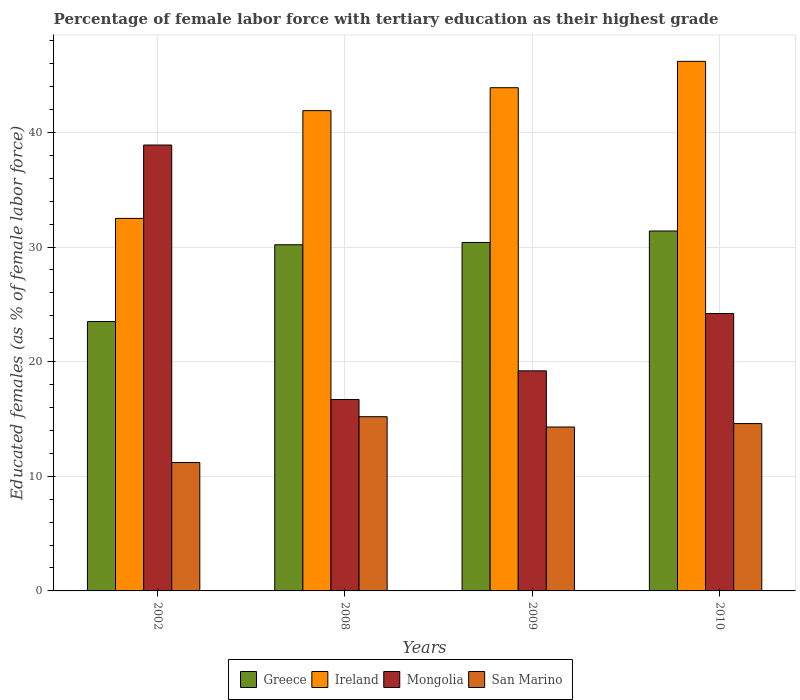In how many cases, is the number of bars for a given year not equal to the number of legend labels?
Ensure brevity in your answer.  0. What is the percentage of female labor force with tertiary education in Ireland in 2002?
Ensure brevity in your answer.  32.5. Across all years, what is the maximum percentage of female labor force with tertiary education in Greece?
Your response must be concise. 31.4. Across all years, what is the minimum percentage of female labor force with tertiary education in Mongolia?
Keep it short and to the point. 16.7. What is the total percentage of female labor force with tertiary education in Ireland in the graph?
Provide a succinct answer. 164.5. What is the difference between the percentage of female labor force with tertiary education in San Marino in 2009 and that in 2010?
Offer a terse response. -0.3. What is the difference between the percentage of female labor force with tertiary education in Greece in 2009 and the percentage of female labor force with tertiary education in Mongolia in 2002?
Ensure brevity in your answer.  -8.5. What is the average percentage of female labor force with tertiary education in Mongolia per year?
Keep it short and to the point. 24.75. In the year 2010, what is the difference between the percentage of female labor force with tertiary education in Mongolia and percentage of female labor force with tertiary education in Greece?
Provide a short and direct response. -7.2. What is the ratio of the percentage of female labor force with tertiary education in Ireland in 2009 to that in 2010?
Give a very brief answer. 0.95. Is the difference between the percentage of female labor force with tertiary education in Mongolia in 2002 and 2008 greater than the difference between the percentage of female labor force with tertiary education in Greece in 2002 and 2008?
Offer a very short reply. Yes. Is it the case that in every year, the sum of the percentage of female labor force with tertiary education in Mongolia and percentage of female labor force with tertiary education in San Marino is greater than the sum of percentage of female labor force with tertiary education in Ireland and percentage of female labor force with tertiary education in Greece?
Your response must be concise. No. What does the 3rd bar from the right in 2009 represents?
Ensure brevity in your answer.  Ireland. How many bars are there?
Your answer should be compact. 16. Are all the bars in the graph horizontal?
Your response must be concise. No. Are the values on the major ticks of Y-axis written in scientific E-notation?
Your response must be concise. No. Does the graph contain any zero values?
Make the answer very short. No. Does the graph contain grids?
Provide a short and direct response. Yes. Where does the legend appear in the graph?
Give a very brief answer. Bottom center. How many legend labels are there?
Offer a terse response. 4. How are the legend labels stacked?
Your answer should be compact. Horizontal. What is the title of the graph?
Provide a short and direct response. Percentage of female labor force with tertiary education as their highest grade. Does "Saudi Arabia" appear as one of the legend labels in the graph?
Ensure brevity in your answer.  No. What is the label or title of the X-axis?
Offer a very short reply. Years. What is the label or title of the Y-axis?
Make the answer very short. Educated females (as % of female labor force). What is the Educated females (as % of female labor force) in Greece in 2002?
Give a very brief answer. 23.5. What is the Educated females (as % of female labor force) in Ireland in 2002?
Offer a terse response. 32.5. What is the Educated females (as % of female labor force) in Mongolia in 2002?
Provide a succinct answer. 38.9. What is the Educated females (as % of female labor force) of San Marino in 2002?
Your answer should be compact. 11.2. What is the Educated females (as % of female labor force) of Greece in 2008?
Your answer should be compact. 30.2. What is the Educated females (as % of female labor force) of Ireland in 2008?
Offer a terse response. 41.9. What is the Educated females (as % of female labor force) in Mongolia in 2008?
Give a very brief answer. 16.7. What is the Educated females (as % of female labor force) in San Marino in 2008?
Offer a very short reply. 15.2. What is the Educated females (as % of female labor force) of Greece in 2009?
Ensure brevity in your answer.  30.4. What is the Educated females (as % of female labor force) of Ireland in 2009?
Keep it short and to the point. 43.9. What is the Educated females (as % of female labor force) of Mongolia in 2009?
Provide a short and direct response. 19.2. What is the Educated females (as % of female labor force) of San Marino in 2009?
Provide a succinct answer. 14.3. What is the Educated females (as % of female labor force) of Greece in 2010?
Your answer should be very brief. 31.4. What is the Educated females (as % of female labor force) in Ireland in 2010?
Provide a succinct answer. 46.2. What is the Educated females (as % of female labor force) of Mongolia in 2010?
Provide a succinct answer. 24.2. What is the Educated females (as % of female labor force) in San Marino in 2010?
Your response must be concise. 14.6. Across all years, what is the maximum Educated females (as % of female labor force) in Greece?
Provide a short and direct response. 31.4. Across all years, what is the maximum Educated females (as % of female labor force) in Ireland?
Your answer should be very brief. 46.2. Across all years, what is the maximum Educated females (as % of female labor force) in Mongolia?
Provide a short and direct response. 38.9. Across all years, what is the maximum Educated females (as % of female labor force) in San Marino?
Offer a terse response. 15.2. Across all years, what is the minimum Educated females (as % of female labor force) in Greece?
Provide a succinct answer. 23.5. Across all years, what is the minimum Educated females (as % of female labor force) in Ireland?
Your answer should be very brief. 32.5. Across all years, what is the minimum Educated females (as % of female labor force) of Mongolia?
Your response must be concise. 16.7. Across all years, what is the minimum Educated females (as % of female labor force) of San Marino?
Your response must be concise. 11.2. What is the total Educated females (as % of female labor force) of Greece in the graph?
Offer a very short reply. 115.5. What is the total Educated females (as % of female labor force) of Ireland in the graph?
Your response must be concise. 164.5. What is the total Educated females (as % of female labor force) of Mongolia in the graph?
Make the answer very short. 99. What is the total Educated females (as % of female labor force) of San Marino in the graph?
Your answer should be compact. 55.3. What is the difference between the Educated females (as % of female labor force) in Mongolia in 2002 and that in 2009?
Your response must be concise. 19.7. What is the difference between the Educated females (as % of female labor force) of San Marino in 2002 and that in 2009?
Provide a short and direct response. -3.1. What is the difference between the Educated females (as % of female labor force) in Greece in 2002 and that in 2010?
Your response must be concise. -7.9. What is the difference between the Educated females (as % of female labor force) in Ireland in 2002 and that in 2010?
Ensure brevity in your answer.  -13.7. What is the difference between the Educated females (as % of female labor force) of Ireland in 2008 and that in 2010?
Give a very brief answer. -4.3. What is the difference between the Educated females (as % of female labor force) in Mongolia in 2008 and that in 2010?
Keep it short and to the point. -7.5. What is the difference between the Educated females (as % of female labor force) of San Marino in 2008 and that in 2010?
Provide a succinct answer. 0.6. What is the difference between the Educated females (as % of female labor force) of Greece in 2009 and that in 2010?
Provide a succinct answer. -1. What is the difference between the Educated females (as % of female labor force) of Ireland in 2009 and that in 2010?
Keep it short and to the point. -2.3. What is the difference between the Educated females (as % of female labor force) of San Marino in 2009 and that in 2010?
Offer a terse response. -0.3. What is the difference between the Educated females (as % of female labor force) of Greece in 2002 and the Educated females (as % of female labor force) of Ireland in 2008?
Make the answer very short. -18.4. What is the difference between the Educated females (as % of female labor force) of Greece in 2002 and the Educated females (as % of female labor force) of Mongolia in 2008?
Keep it short and to the point. 6.8. What is the difference between the Educated females (as % of female labor force) in Greece in 2002 and the Educated females (as % of female labor force) in San Marino in 2008?
Your answer should be compact. 8.3. What is the difference between the Educated females (as % of female labor force) in Mongolia in 2002 and the Educated females (as % of female labor force) in San Marino in 2008?
Provide a short and direct response. 23.7. What is the difference between the Educated females (as % of female labor force) in Greece in 2002 and the Educated females (as % of female labor force) in Ireland in 2009?
Make the answer very short. -20.4. What is the difference between the Educated females (as % of female labor force) of Greece in 2002 and the Educated females (as % of female labor force) of Mongolia in 2009?
Offer a very short reply. 4.3. What is the difference between the Educated females (as % of female labor force) in Ireland in 2002 and the Educated females (as % of female labor force) in San Marino in 2009?
Your answer should be very brief. 18.2. What is the difference between the Educated females (as % of female labor force) of Mongolia in 2002 and the Educated females (as % of female labor force) of San Marino in 2009?
Provide a succinct answer. 24.6. What is the difference between the Educated females (as % of female labor force) of Greece in 2002 and the Educated females (as % of female labor force) of Ireland in 2010?
Provide a succinct answer. -22.7. What is the difference between the Educated females (as % of female labor force) of Greece in 2002 and the Educated females (as % of female labor force) of Mongolia in 2010?
Provide a short and direct response. -0.7. What is the difference between the Educated females (as % of female labor force) of Ireland in 2002 and the Educated females (as % of female labor force) of San Marino in 2010?
Give a very brief answer. 17.9. What is the difference between the Educated females (as % of female labor force) in Mongolia in 2002 and the Educated females (as % of female labor force) in San Marino in 2010?
Offer a very short reply. 24.3. What is the difference between the Educated females (as % of female labor force) in Greece in 2008 and the Educated females (as % of female labor force) in Ireland in 2009?
Provide a short and direct response. -13.7. What is the difference between the Educated females (as % of female labor force) of Ireland in 2008 and the Educated females (as % of female labor force) of Mongolia in 2009?
Provide a short and direct response. 22.7. What is the difference between the Educated females (as % of female labor force) of Ireland in 2008 and the Educated females (as % of female labor force) of San Marino in 2009?
Provide a short and direct response. 27.6. What is the difference between the Educated females (as % of female labor force) in Greece in 2008 and the Educated females (as % of female labor force) in Ireland in 2010?
Give a very brief answer. -16. What is the difference between the Educated females (as % of female labor force) in Greece in 2008 and the Educated females (as % of female labor force) in Mongolia in 2010?
Offer a terse response. 6. What is the difference between the Educated females (as % of female labor force) of Ireland in 2008 and the Educated females (as % of female labor force) of Mongolia in 2010?
Your answer should be very brief. 17.7. What is the difference between the Educated females (as % of female labor force) in Ireland in 2008 and the Educated females (as % of female labor force) in San Marino in 2010?
Offer a very short reply. 27.3. What is the difference between the Educated females (as % of female labor force) in Mongolia in 2008 and the Educated females (as % of female labor force) in San Marino in 2010?
Your answer should be compact. 2.1. What is the difference between the Educated females (as % of female labor force) in Greece in 2009 and the Educated females (as % of female labor force) in Ireland in 2010?
Give a very brief answer. -15.8. What is the difference between the Educated females (as % of female labor force) of Greece in 2009 and the Educated females (as % of female labor force) of San Marino in 2010?
Offer a very short reply. 15.8. What is the difference between the Educated females (as % of female labor force) in Ireland in 2009 and the Educated females (as % of female labor force) in San Marino in 2010?
Make the answer very short. 29.3. What is the average Educated females (as % of female labor force) of Greece per year?
Make the answer very short. 28.88. What is the average Educated females (as % of female labor force) in Ireland per year?
Your answer should be very brief. 41.12. What is the average Educated females (as % of female labor force) of Mongolia per year?
Your answer should be very brief. 24.75. What is the average Educated females (as % of female labor force) of San Marino per year?
Your answer should be very brief. 13.82. In the year 2002, what is the difference between the Educated females (as % of female labor force) in Greece and Educated females (as % of female labor force) in Mongolia?
Give a very brief answer. -15.4. In the year 2002, what is the difference between the Educated females (as % of female labor force) in Ireland and Educated females (as % of female labor force) in Mongolia?
Provide a short and direct response. -6.4. In the year 2002, what is the difference between the Educated females (as % of female labor force) in Ireland and Educated females (as % of female labor force) in San Marino?
Provide a short and direct response. 21.3. In the year 2002, what is the difference between the Educated females (as % of female labor force) of Mongolia and Educated females (as % of female labor force) of San Marino?
Your response must be concise. 27.7. In the year 2008, what is the difference between the Educated females (as % of female labor force) of Greece and Educated females (as % of female labor force) of San Marino?
Make the answer very short. 15. In the year 2008, what is the difference between the Educated females (as % of female labor force) in Ireland and Educated females (as % of female labor force) in Mongolia?
Your response must be concise. 25.2. In the year 2008, what is the difference between the Educated females (as % of female labor force) of Ireland and Educated females (as % of female labor force) of San Marino?
Provide a short and direct response. 26.7. In the year 2008, what is the difference between the Educated females (as % of female labor force) in Mongolia and Educated females (as % of female labor force) in San Marino?
Ensure brevity in your answer.  1.5. In the year 2009, what is the difference between the Educated females (as % of female labor force) in Greece and Educated females (as % of female labor force) in Ireland?
Provide a succinct answer. -13.5. In the year 2009, what is the difference between the Educated females (as % of female labor force) in Ireland and Educated females (as % of female labor force) in Mongolia?
Give a very brief answer. 24.7. In the year 2009, what is the difference between the Educated females (as % of female labor force) in Ireland and Educated females (as % of female labor force) in San Marino?
Your response must be concise. 29.6. In the year 2010, what is the difference between the Educated females (as % of female labor force) of Greece and Educated females (as % of female labor force) of Ireland?
Ensure brevity in your answer.  -14.8. In the year 2010, what is the difference between the Educated females (as % of female labor force) of Greece and Educated females (as % of female labor force) of San Marino?
Provide a short and direct response. 16.8. In the year 2010, what is the difference between the Educated females (as % of female labor force) of Ireland and Educated females (as % of female labor force) of Mongolia?
Your response must be concise. 22. In the year 2010, what is the difference between the Educated females (as % of female labor force) in Ireland and Educated females (as % of female labor force) in San Marino?
Give a very brief answer. 31.6. In the year 2010, what is the difference between the Educated females (as % of female labor force) in Mongolia and Educated females (as % of female labor force) in San Marino?
Ensure brevity in your answer.  9.6. What is the ratio of the Educated females (as % of female labor force) in Greece in 2002 to that in 2008?
Provide a short and direct response. 0.78. What is the ratio of the Educated females (as % of female labor force) of Ireland in 2002 to that in 2008?
Provide a short and direct response. 0.78. What is the ratio of the Educated females (as % of female labor force) in Mongolia in 2002 to that in 2008?
Offer a very short reply. 2.33. What is the ratio of the Educated females (as % of female labor force) in San Marino in 2002 to that in 2008?
Your answer should be compact. 0.74. What is the ratio of the Educated females (as % of female labor force) of Greece in 2002 to that in 2009?
Your answer should be very brief. 0.77. What is the ratio of the Educated females (as % of female labor force) in Ireland in 2002 to that in 2009?
Offer a terse response. 0.74. What is the ratio of the Educated females (as % of female labor force) of Mongolia in 2002 to that in 2009?
Offer a terse response. 2.03. What is the ratio of the Educated females (as % of female labor force) in San Marino in 2002 to that in 2009?
Make the answer very short. 0.78. What is the ratio of the Educated females (as % of female labor force) in Greece in 2002 to that in 2010?
Ensure brevity in your answer.  0.75. What is the ratio of the Educated females (as % of female labor force) in Ireland in 2002 to that in 2010?
Your response must be concise. 0.7. What is the ratio of the Educated females (as % of female labor force) of Mongolia in 2002 to that in 2010?
Give a very brief answer. 1.61. What is the ratio of the Educated females (as % of female labor force) of San Marino in 2002 to that in 2010?
Give a very brief answer. 0.77. What is the ratio of the Educated females (as % of female labor force) in Greece in 2008 to that in 2009?
Your answer should be very brief. 0.99. What is the ratio of the Educated females (as % of female labor force) of Ireland in 2008 to that in 2009?
Offer a terse response. 0.95. What is the ratio of the Educated females (as % of female labor force) in Mongolia in 2008 to that in 2009?
Offer a terse response. 0.87. What is the ratio of the Educated females (as % of female labor force) of San Marino in 2008 to that in 2009?
Offer a very short reply. 1.06. What is the ratio of the Educated females (as % of female labor force) of Greece in 2008 to that in 2010?
Your answer should be compact. 0.96. What is the ratio of the Educated females (as % of female labor force) of Ireland in 2008 to that in 2010?
Provide a short and direct response. 0.91. What is the ratio of the Educated females (as % of female labor force) in Mongolia in 2008 to that in 2010?
Ensure brevity in your answer.  0.69. What is the ratio of the Educated females (as % of female labor force) of San Marino in 2008 to that in 2010?
Offer a terse response. 1.04. What is the ratio of the Educated females (as % of female labor force) in Greece in 2009 to that in 2010?
Offer a terse response. 0.97. What is the ratio of the Educated females (as % of female labor force) of Ireland in 2009 to that in 2010?
Provide a short and direct response. 0.95. What is the ratio of the Educated females (as % of female labor force) in Mongolia in 2009 to that in 2010?
Make the answer very short. 0.79. What is the ratio of the Educated females (as % of female labor force) in San Marino in 2009 to that in 2010?
Give a very brief answer. 0.98. What is the difference between the highest and the second highest Educated females (as % of female labor force) of Greece?
Make the answer very short. 1. What is the difference between the highest and the second highest Educated females (as % of female labor force) of Ireland?
Offer a terse response. 2.3. What is the difference between the highest and the second highest Educated females (as % of female labor force) in San Marino?
Make the answer very short. 0.6. 